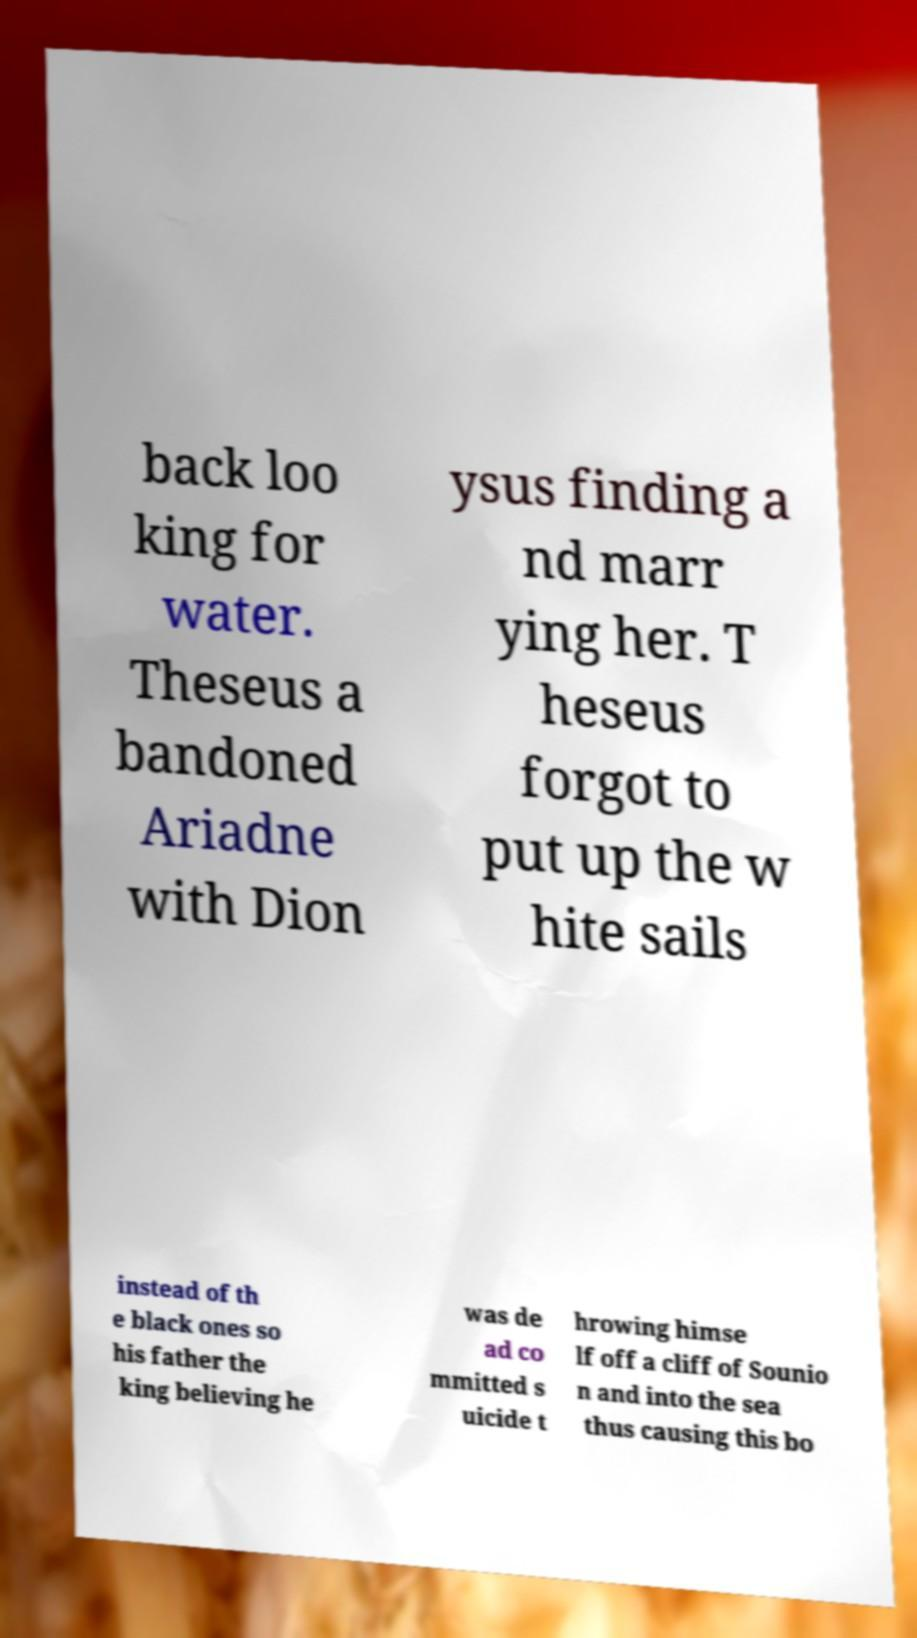Please read and relay the text visible in this image. What does it say? back loo king for water. Theseus a bandoned Ariadne with Dion ysus finding a nd marr ying her. T heseus forgot to put up the w hite sails instead of th e black ones so his father the king believing he was de ad co mmitted s uicide t hrowing himse lf off a cliff of Sounio n and into the sea thus causing this bo 